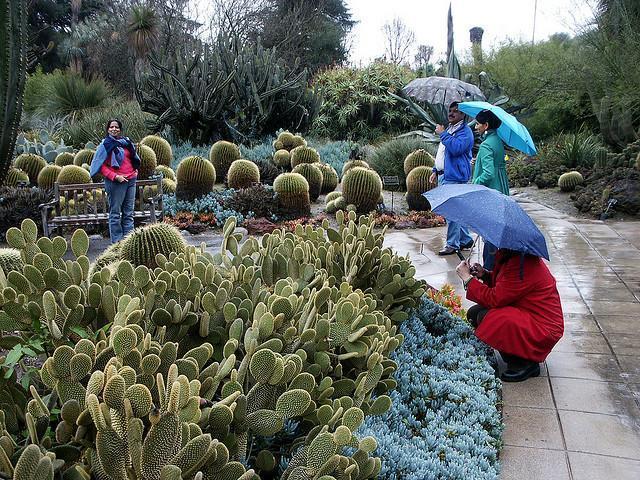What do these plants need very little of?
Select the correct answer and articulate reasoning with the following format: 'Answer: answer
Rationale: rationale.'
Options: Sun, love, water, heat. Answer: water.
Rationale: These plants are cacti. they live in deserts and similar areas that are sunny and dry. 